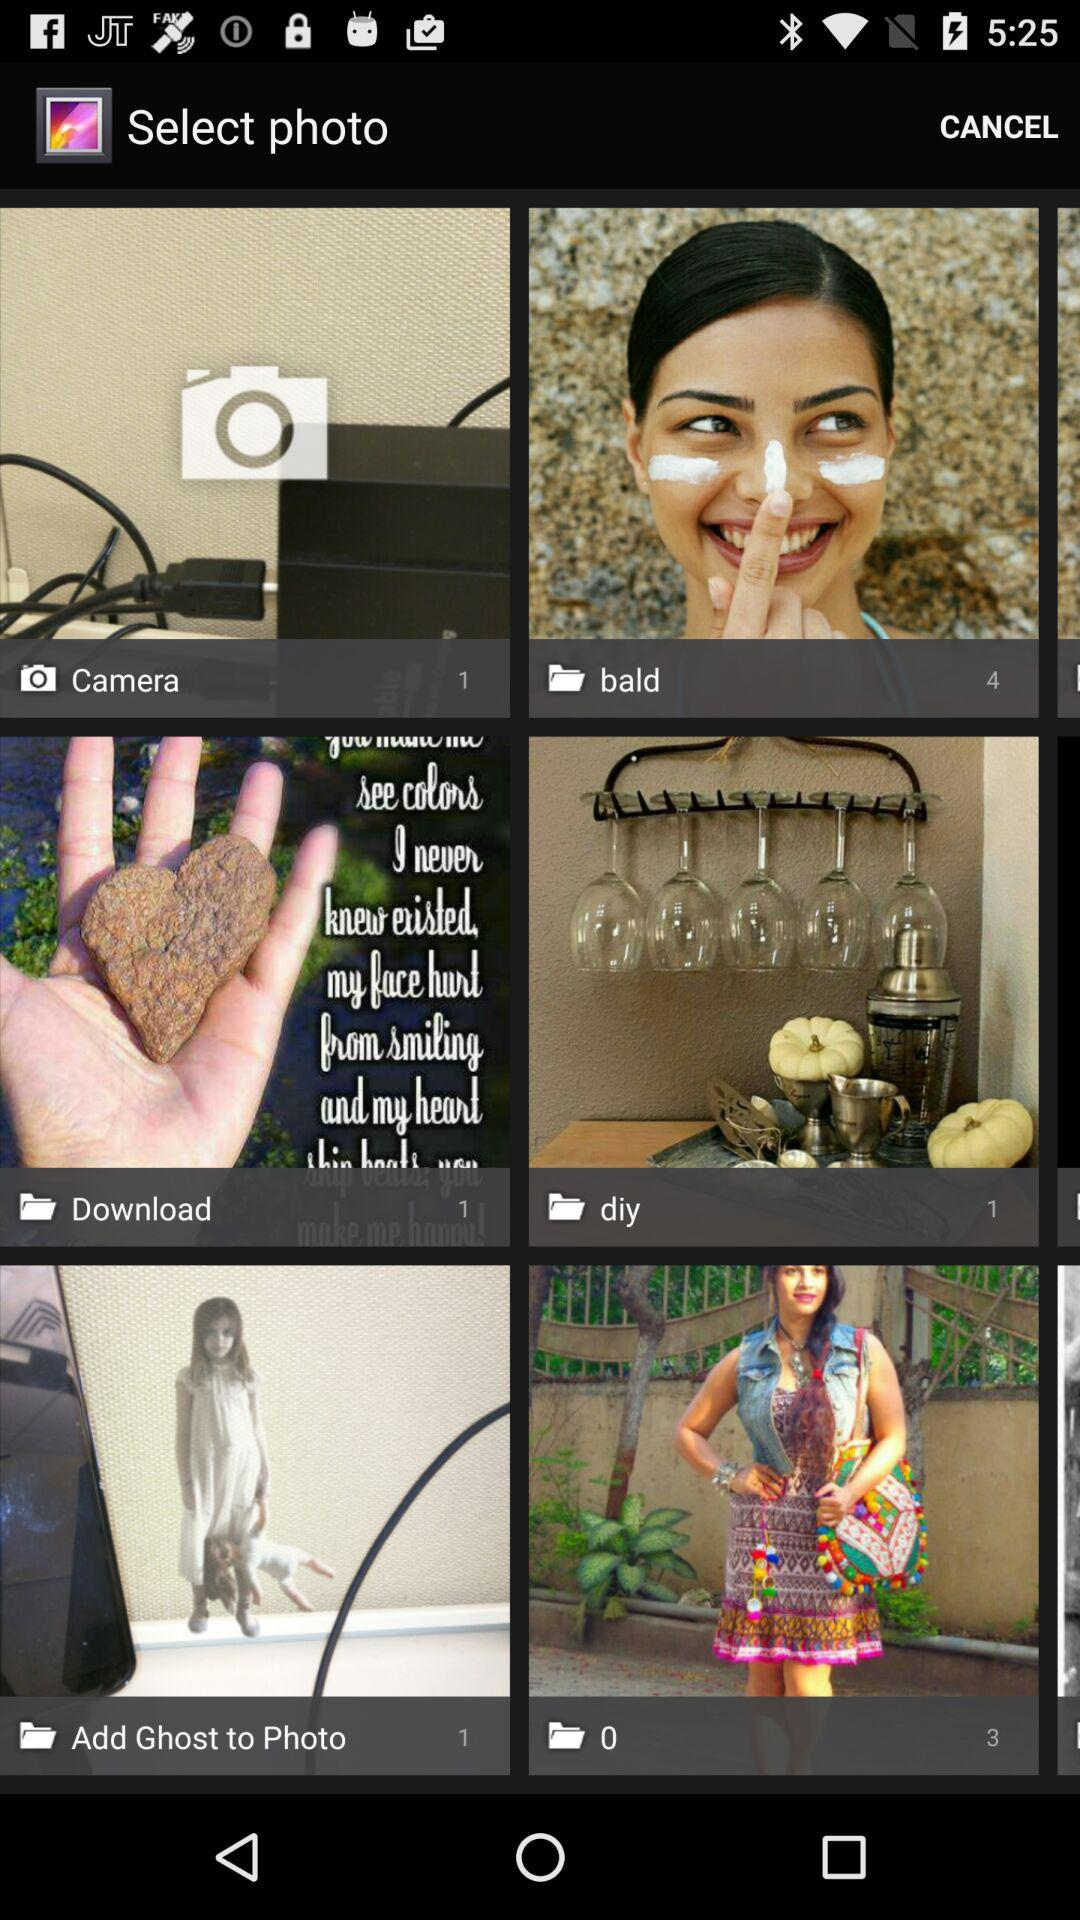How many pictures are in the "Camera" folder? There is 1 picture in the "Camera" folder. 